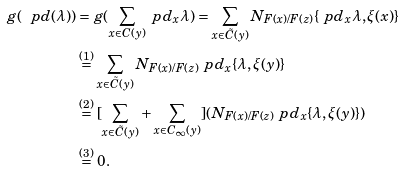Convert formula to latex. <formula><loc_0><loc_0><loc_500><loc_500>g ( \ p d ( \lambda ) ) & = g ( \sum _ { x \in C ( y ) } \ p d _ { x } \lambda ) = \sum _ { x \in \tilde { C } ( y ) } N _ { F ( x ) / F ( z ) } \{ \ p d _ { x } \lambda , \xi ( x ) \} \\ & \overset { ( 1 ) } { = } \sum _ { x \in \tilde { C } ( y ) } N _ { F ( x ) / F ( z ) } \ p d _ { x } \{ \lambda , \xi ( y ) \} \\ & \overset { ( 2 ) } { = } [ \sum _ { x \in \tilde { C } ( y ) } + \sum _ { x \in C _ { \infty } ( y ) } ] ( N _ { F ( x ) / F ( z ) } \ p d _ { x } \{ \lambda , \xi ( y ) \} ) \\ & \overset { ( 3 ) } { = } 0 .</formula> 